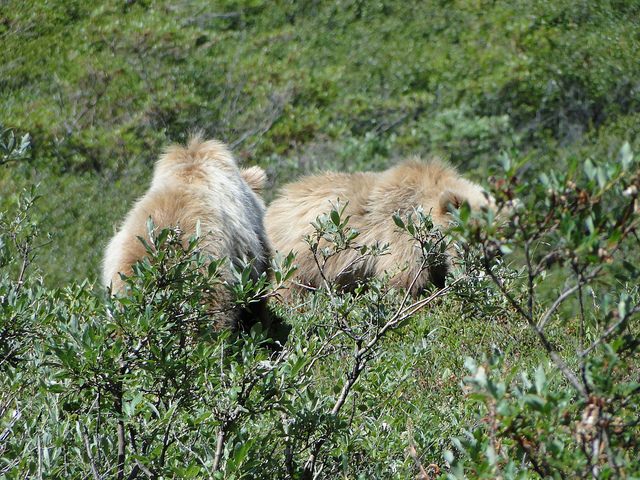How many animals are in the photo? 2 